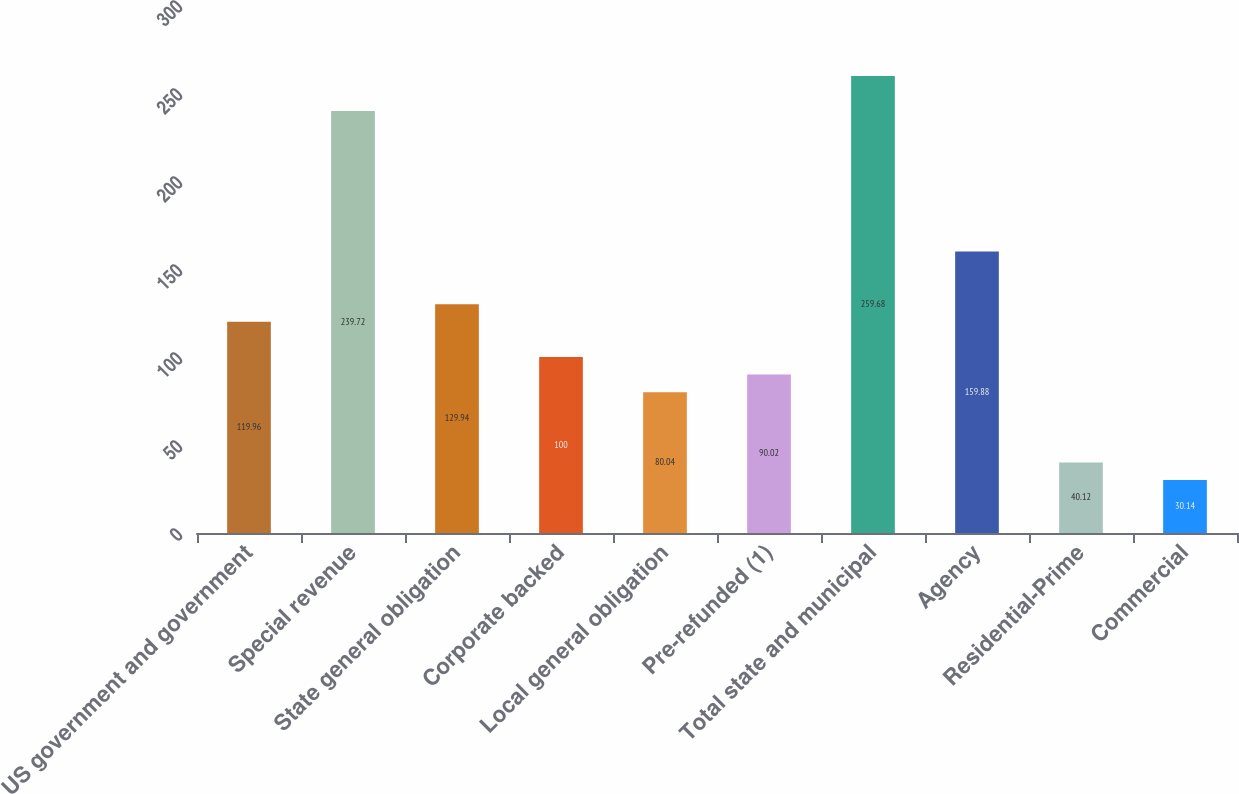Convert chart. <chart><loc_0><loc_0><loc_500><loc_500><bar_chart><fcel>US government and government<fcel>Special revenue<fcel>State general obligation<fcel>Corporate backed<fcel>Local general obligation<fcel>Pre-refunded (1)<fcel>Total state and municipal<fcel>Agency<fcel>Residential-Prime<fcel>Commercial<nl><fcel>119.96<fcel>239.72<fcel>129.94<fcel>100<fcel>80.04<fcel>90.02<fcel>259.68<fcel>159.88<fcel>40.12<fcel>30.14<nl></chart> 